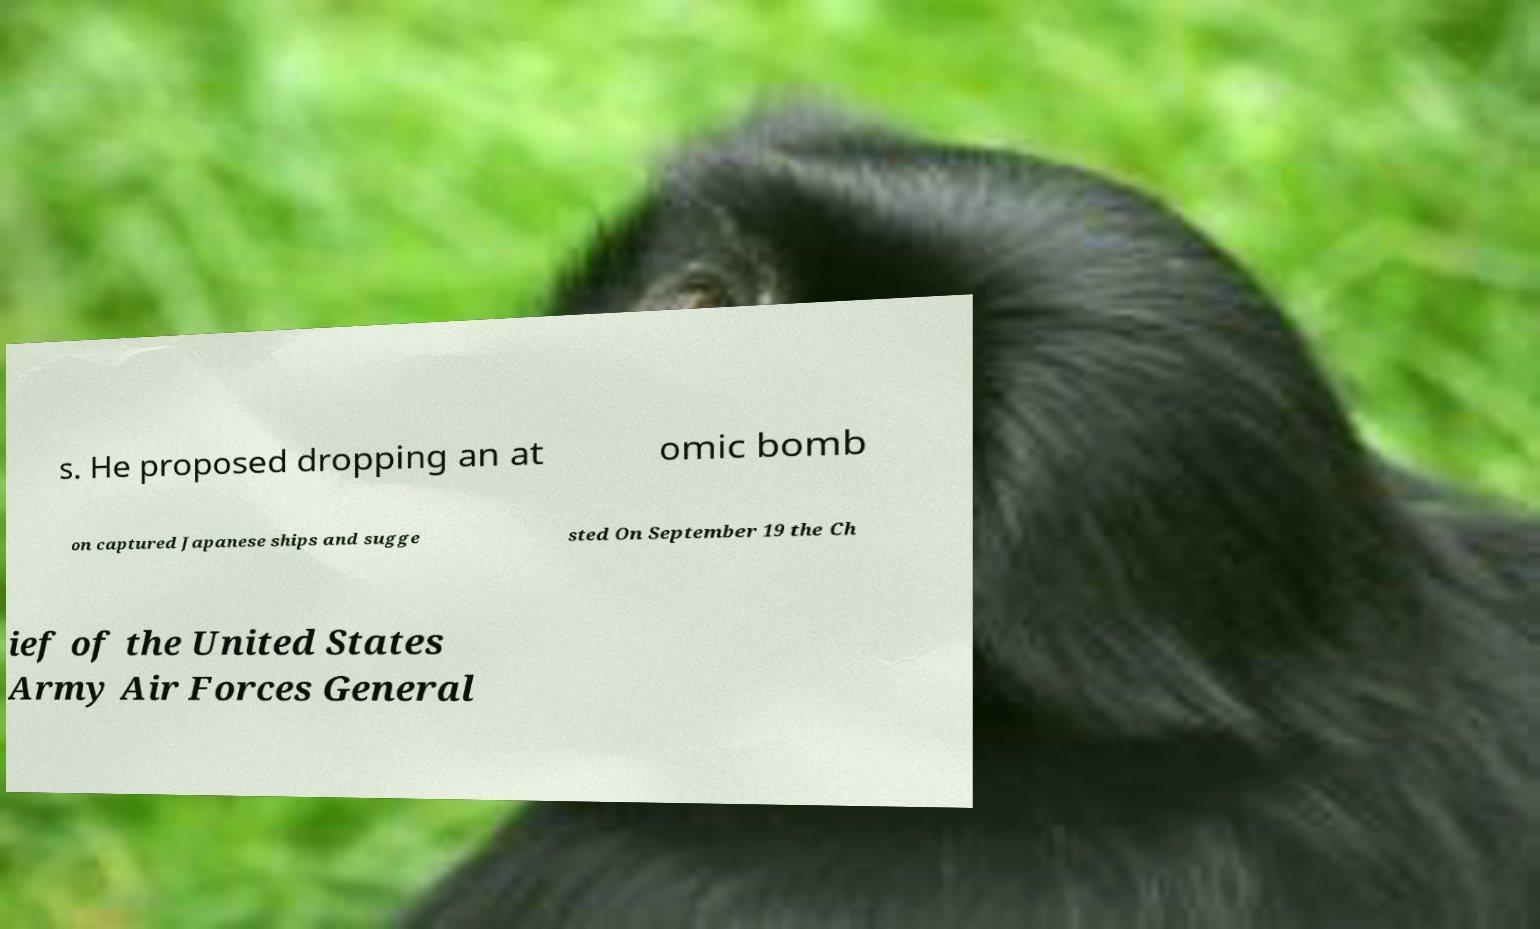Can you read and provide the text displayed in the image?This photo seems to have some interesting text. Can you extract and type it out for me? s. He proposed dropping an at omic bomb on captured Japanese ships and sugge sted On September 19 the Ch ief of the United States Army Air Forces General 